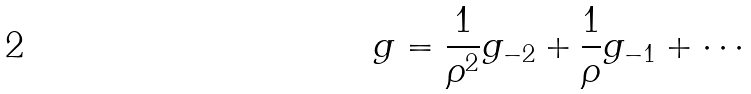Convert formula to latex. <formula><loc_0><loc_0><loc_500><loc_500>g = \frac { 1 } { \rho ^ { 2 } } g _ { - 2 } + \frac { 1 } { \rho } g _ { - 1 } + \cdots</formula> 